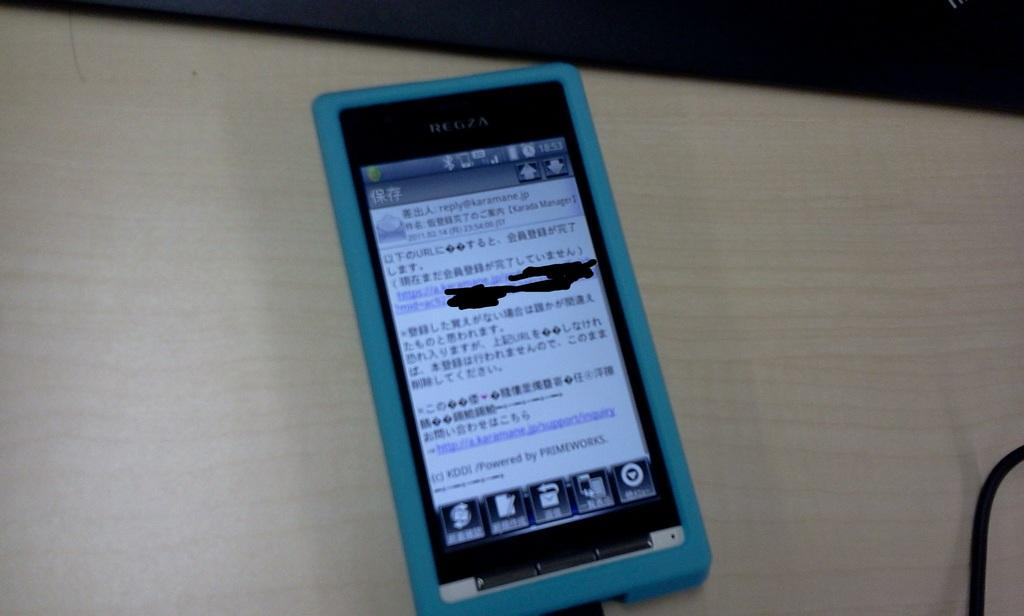<image>
Render a clear and concise summary of the photo. a smartphone with a blue case open to an email from reply@karamane.jp 